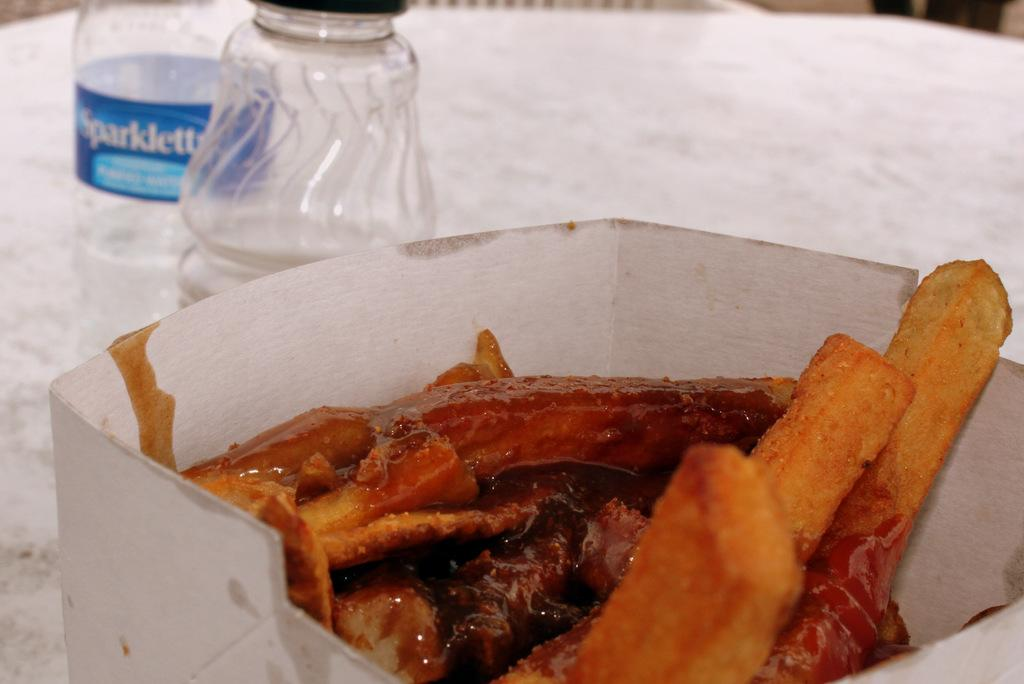What is inside the box that is visible in the image? There is a box in the image containing french fries and sauce. What other items can be seen on the table in the image? There is a jar and a water bottle visible on the table in the image. What might be used for drinking in the image? The water bottle in the image might be used for drinking. What type of credit can be seen on the table in the image? There is no credit present on the table in the image. Can you tell me how many fish are swimming in the jar in the image? There are no fish present in the image; the jar is empty. 